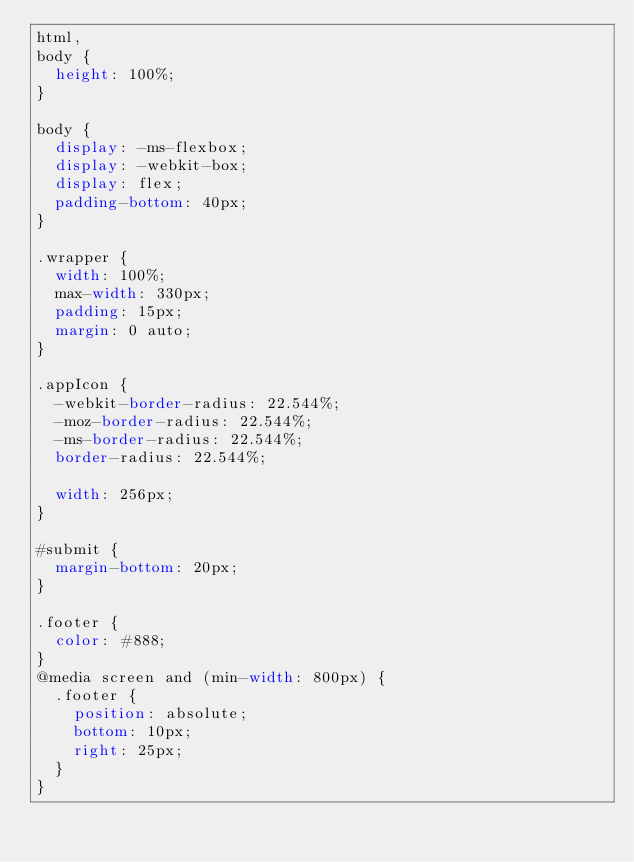<code> <loc_0><loc_0><loc_500><loc_500><_CSS_>html,
body {
  height: 100%;
}

body {
  display: -ms-flexbox;
  display: -webkit-box;
  display: flex;
  padding-bottom: 40px;
}

.wrapper {
  width: 100%;
  max-width: 330px;
  padding: 15px;
  margin: 0 auto;
}

.appIcon {
  -webkit-border-radius: 22.544%;
  -moz-border-radius: 22.544%;
  -ms-border-radius: 22.544%;
  border-radius: 22.544%;

  width: 256px;
}

#submit {
  margin-bottom: 20px;
}

.footer {
  color: #888;
}
@media screen and (min-width: 800px) {
  .footer {
    position: absolute;
    bottom: 10px;
    right: 25px;
  }
}
</code> 